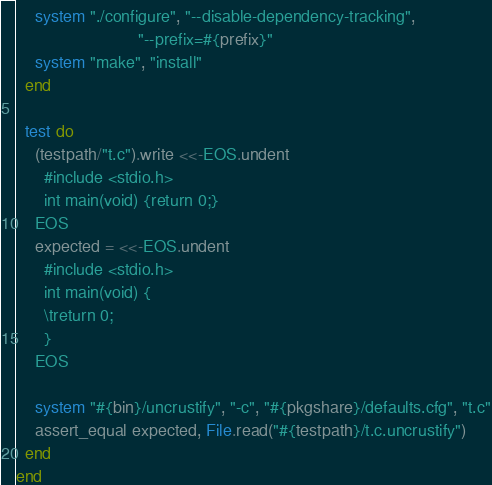<code> <loc_0><loc_0><loc_500><loc_500><_Ruby_>    system "./configure", "--disable-dependency-tracking",
                          "--prefix=#{prefix}"
    system "make", "install"
  end

  test do
    (testpath/"t.c").write <<-EOS.undent
      #include <stdio.h>
      int main(void) {return 0;}
    EOS
    expected = <<-EOS.undent
      #include <stdio.h>
      int main(void) {
      \treturn 0;
      }
    EOS

    system "#{bin}/uncrustify", "-c", "#{pkgshare}/defaults.cfg", "t.c"
    assert_equal expected, File.read("#{testpath}/t.c.uncrustify")
  end
end
</code> 